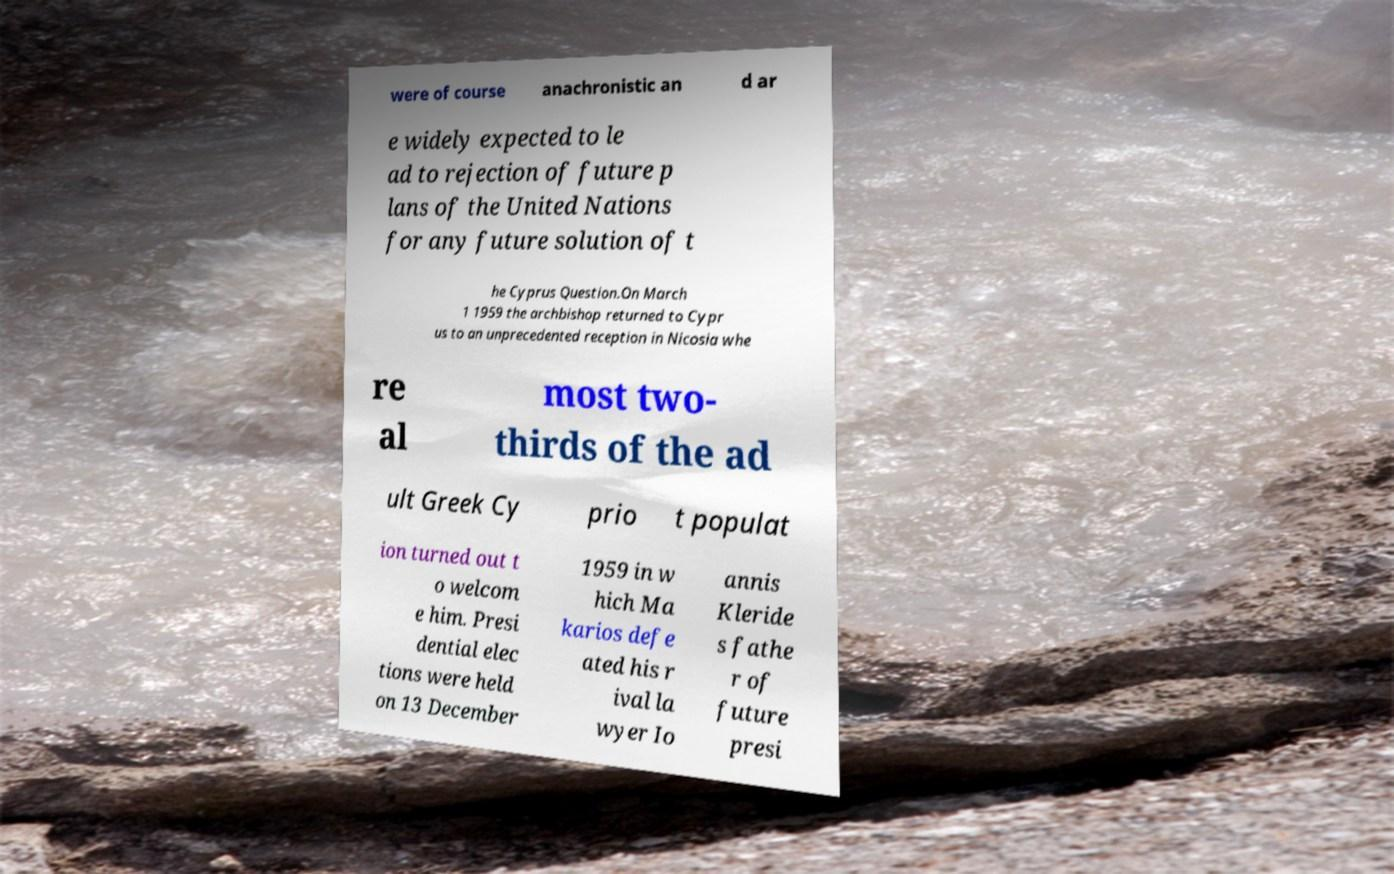For documentation purposes, I need the text within this image transcribed. Could you provide that? were of course anachronistic an d ar e widely expected to le ad to rejection of future p lans of the United Nations for any future solution of t he Cyprus Question.On March 1 1959 the archbishop returned to Cypr us to an unprecedented reception in Nicosia whe re al most two- thirds of the ad ult Greek Cy prio t populat ion turned out t o welcom e him. Presi dential elec tions were held on 13 December 1959 in w hich Ma karios defe ated his r ival la wyer Io annis Kleride s fathe r of future presi 